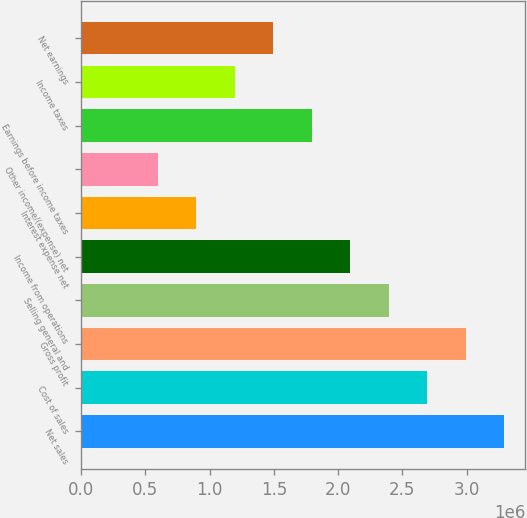Convert chart. <chart><loc_0><loc_0><loc_500><loc_500><bar_chart><fcel>Net sales<fcel>Cost of sales<fcel>Gross profit<fcel>Selling general and<fcel>Income from operations<fcel>Interest expense net<fcel>Other income/(expense) net<fcel>Earnings before income taxes<fcel>Income taxes<fcel>Net earnings<nl><fcel>3.29284e+06<fcel>2.69414e+06<fcel>2.99349e+06<fcel>2.39479e+06<fcel>2.09544e+06<fcel>898050<fcel>598702<fcel>1.7961e+06<fcel>1.1974e+06<fcel>1.49675e+06<nl></chart> 